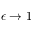<formula> <loc_0><loc_0><loc_500><loc_500>\epsilon \to 1</formula> 